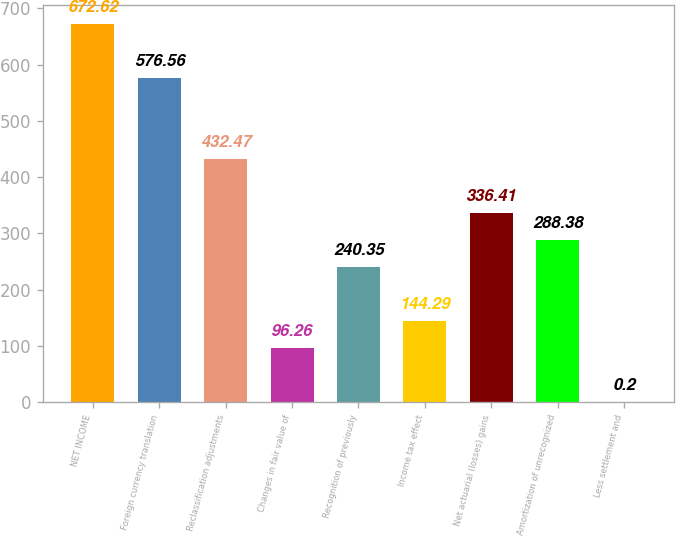Convert chart to OTSL. <chart><loc_0><loc_0><loc_500><loc_500><bar_chart><fcel>NET INCOME<fcel>Foreign currency translation<fcel>Reclassification adjustments<fcel>Changes in fair value of<fcel>Recognition of previously<fcel>Income tax effect<fcel>Net actuarial (losses) gains<fcel>Amortization of unrecognized<fcel>Less settlement and<nl><fcel>672.62<fcel>576.56<fcel>432.47<fcel>96.26<fcel>240.35<fcel>144.29<fcel>336.41<fcel>288.38<fcel>0.2<nl></chart> 